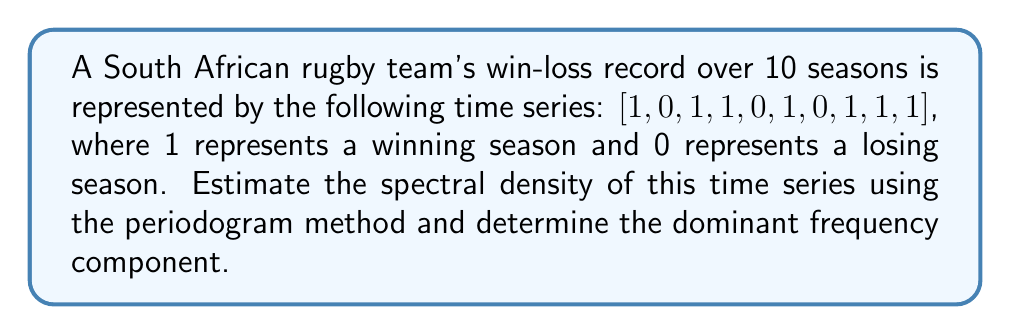Help me with this question. To estimate the spectral density using the periodogram method and find the dominant frequency:

1. Calculate the Discrete Fourier Transform (DFT) of the time series:
   Let $x[n]$ be the time series and $N=10$ be its length.
   $$X[k] = \sum_{n=0}^{N-1} x[n] e^{-i2\pi kn/N}, \quad k = 0, 1, ..., N-1$$

2. Compute the periodogram:
   $$I(f_k) = \frac{1}{N}|X[k]|^2, \quad f_k = \frac{k}{N}, \quad k = 0, 1, ..., N-1$$

3. Calculate the DFT using the FFT algorithm:
   $X = [7, -1+1.31i, -1+0.31i, 1+0.31i, -1-1.31i, 1, -1+1.31i, -1+0.31i, 1+0.31i, -1-1.31i]$

4. Compute the periodogram:
   $I(f_k) = [4.9, 0.34, 0.2, 0.2, 0.34, 0.1, 0.34, 0.2, 0.2, 0.34]$

5. Identify the dominant frequency:
   The maximum value in the periodogram occurs at $k=0$, corresponding to $f_0 = 0$.

6. Interpret the result:
   The dominant frequency at 0 suggests a strong constant component in the time series, which is expected given the team's overall winning record (7 wins out of 10 seasons).
Answer: Dominant frequency: 0 Hz 